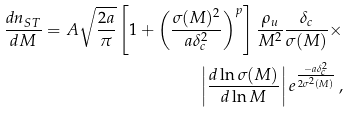<formula> <loc_0><loc_0><loc_500><loc_500>\frac { d n _ { S T } } { d M } = A \sqrt { \frac { 2 a } { \pi } } \left [ 1 + \left ( \frac { \sigma ( M ) ^ { 2 } } { a \delta _ { c } ^ { 2 } } \right ) ^ { p } \right ] \frac { \rho _ { u } } { M ^ { 2 } } \frac { \delta _ { c } } { \sigma ( M ) } \times \\ \left | \frac { d \ln { \sigma ( M ) } } { d \ln { M } } \right | e ^ { \frac { - a \delta _ { c } ^ { 2 } } { 2 \sigma ^ { 2 } ( M ) } } \, ,</formula> 